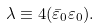<formula> <loc_0><loc_0><loc_500><loc_500>\lambda \equiv 4 ( \bar { \varepsilon } _ { 0 } \varepsilon _ { 0 } ) .</formula> 